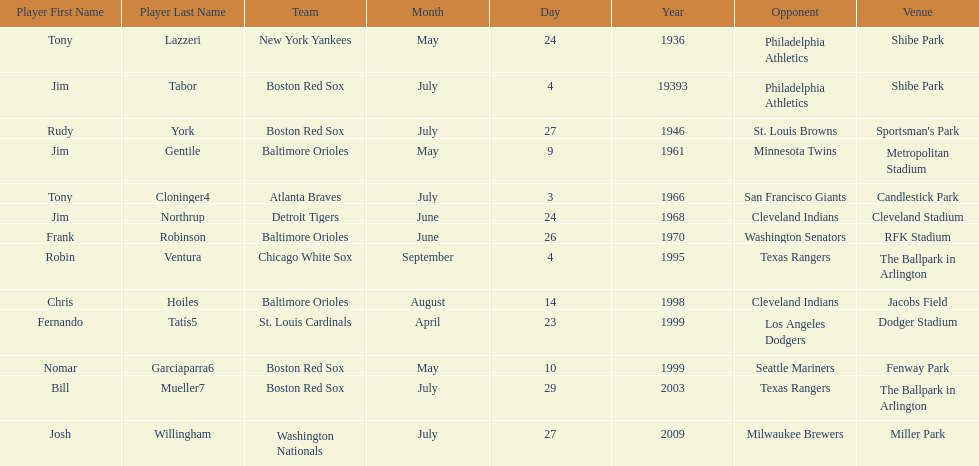What is the name of the player for the new york yankees in 1936? Tony Lazzeri. 